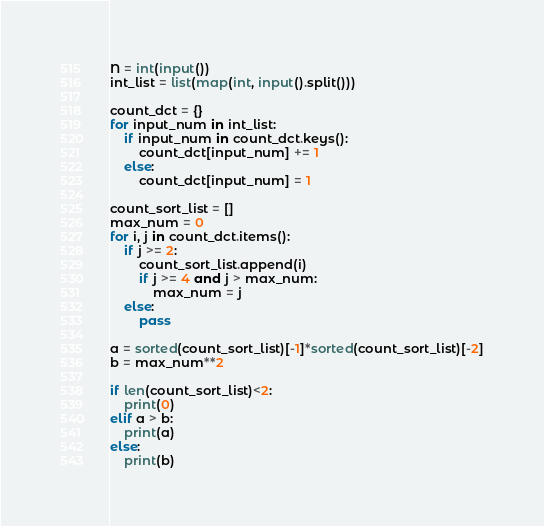Convert code to text. <code><loc_0><loc_0><loc_500><loc_500><_Python_>N = int(input())
int_list = list(map(int, input().split()))

count_dct = {}
for input_num in int_list:
    if input_num in count_dct.keys():
        count_dct[input_num] += 1
    else:
        count_dct[input_num] = 1
        
count_sort_list = []
max_num = 0
for i, j in count_dct.items():
    if j >= 2:
        count_sort_list.append(i)
        if j >= 4 and j > max_num:
            max_num = j
    else:
        pass
      
a = sorted(count_sort_list)[-1]*sorted(count_sort_list)[-2]
b = max_num**2

if len(count_sort_list)<2:
    print(0)
elif a > b:
    print(a)
else:
    print(b)</code> 